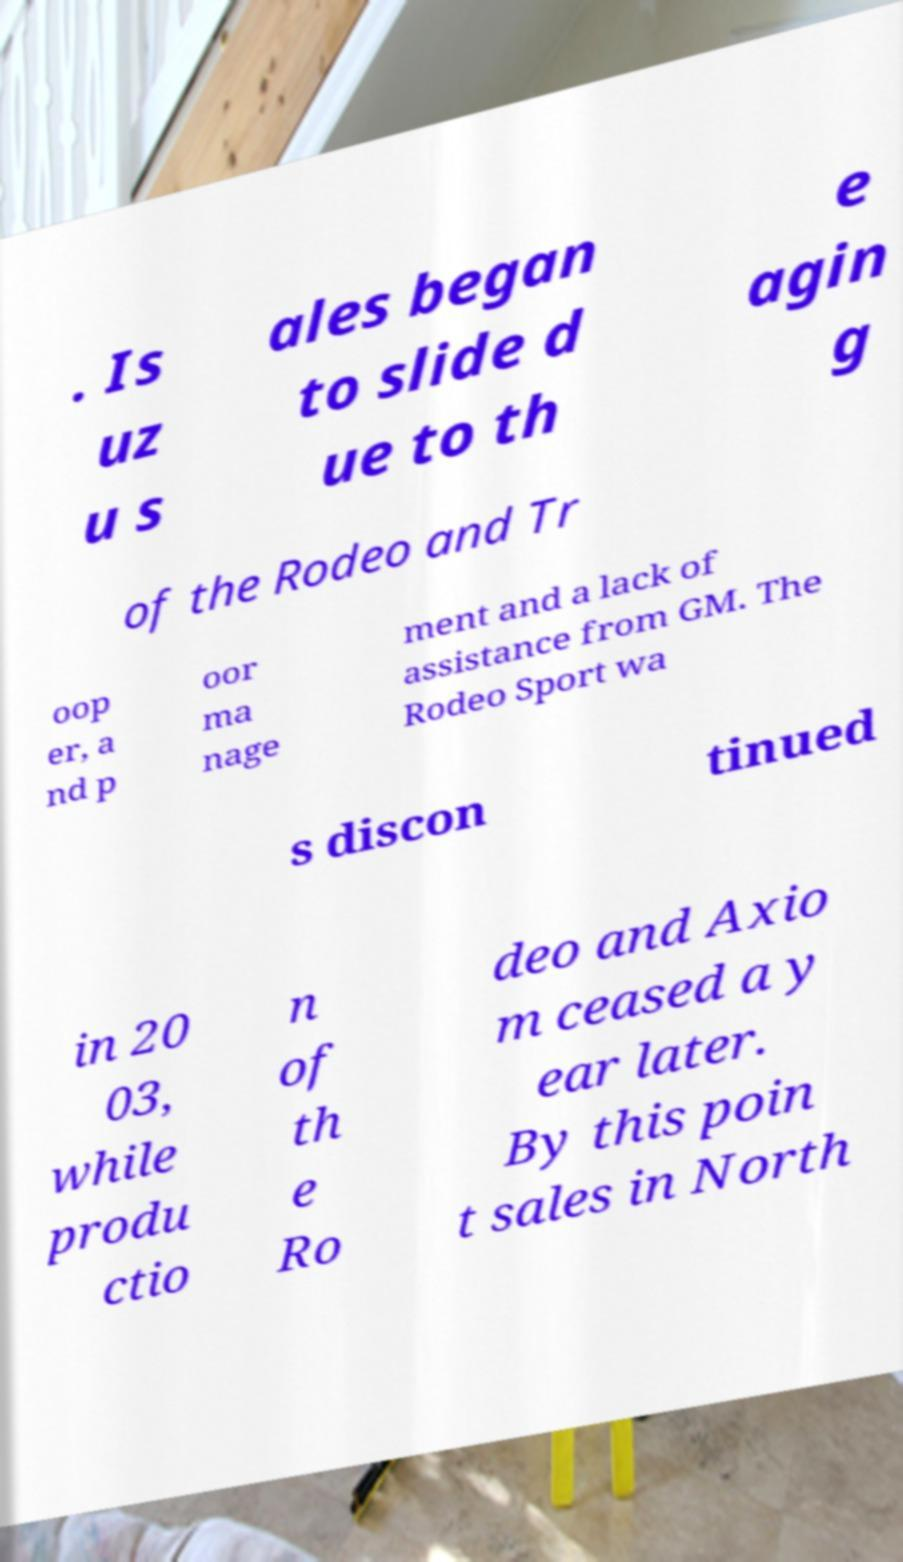What messages or text are displayed in this image? I need them in a readable, typed format. . Is uz u s ales began to slide d ue to th e agin g of the Rodeo and Tr oop er, a nd p oor ma nage ment and a lack of assistance from GM. The Rodeo Sport wa s discon tinued in 20 03, while produ ctio n of th e Ro deo and Axio m ceased a y ear later. By this poin t sales in North 